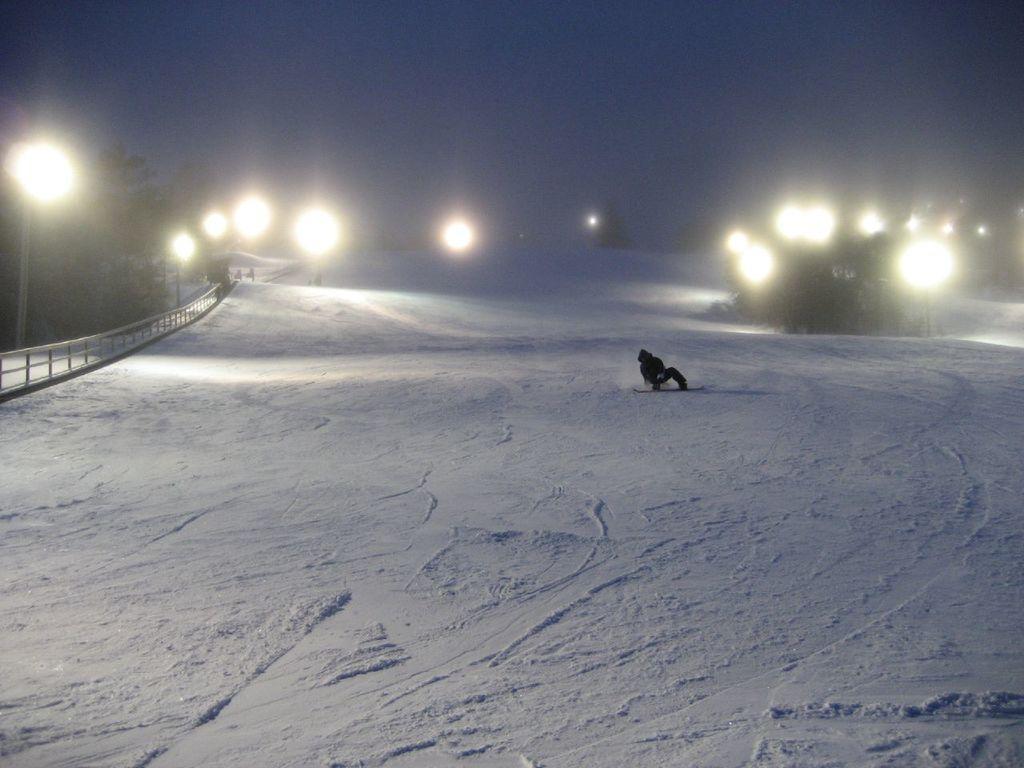How would you summarize this image in a sentence or two? In this image there is one person who is skating in a snow, at the bottom there is snow and in the background there are some lights, trees and on the left side there is a railing. At the top of the image there is sky. 